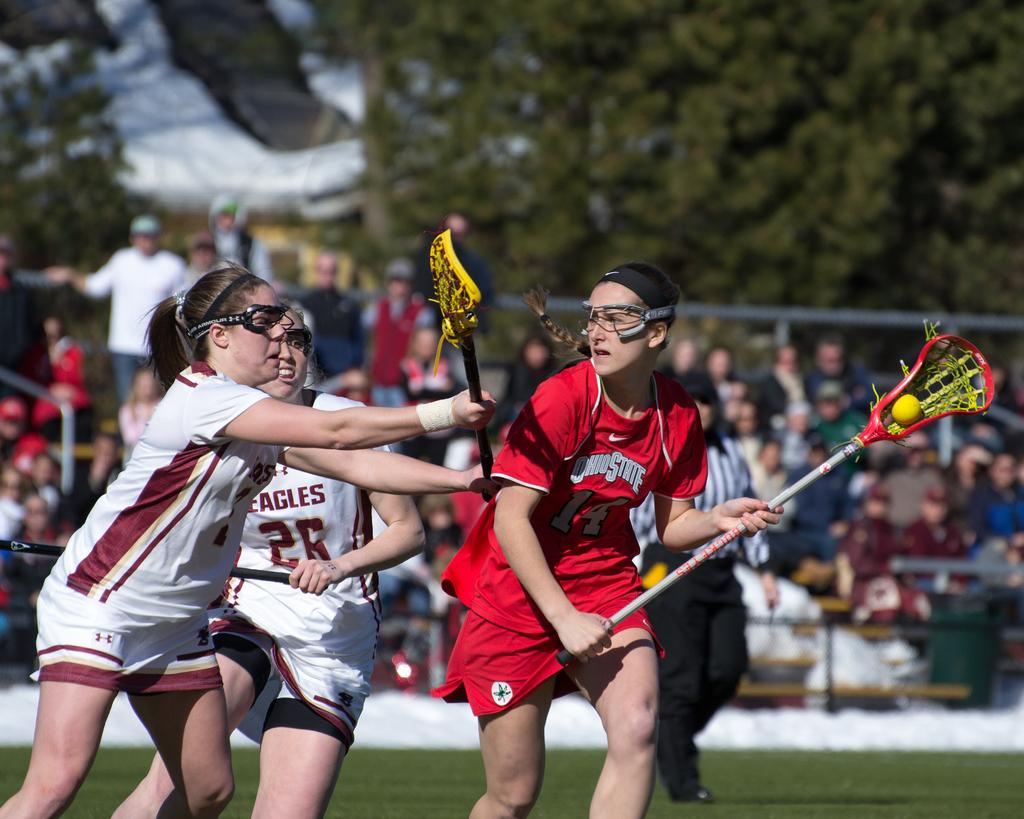<image>
Create a compact narrative representing the image presented. An Ohio State lacrosse player tries to fire a shot in front of two Eagles defenders. 